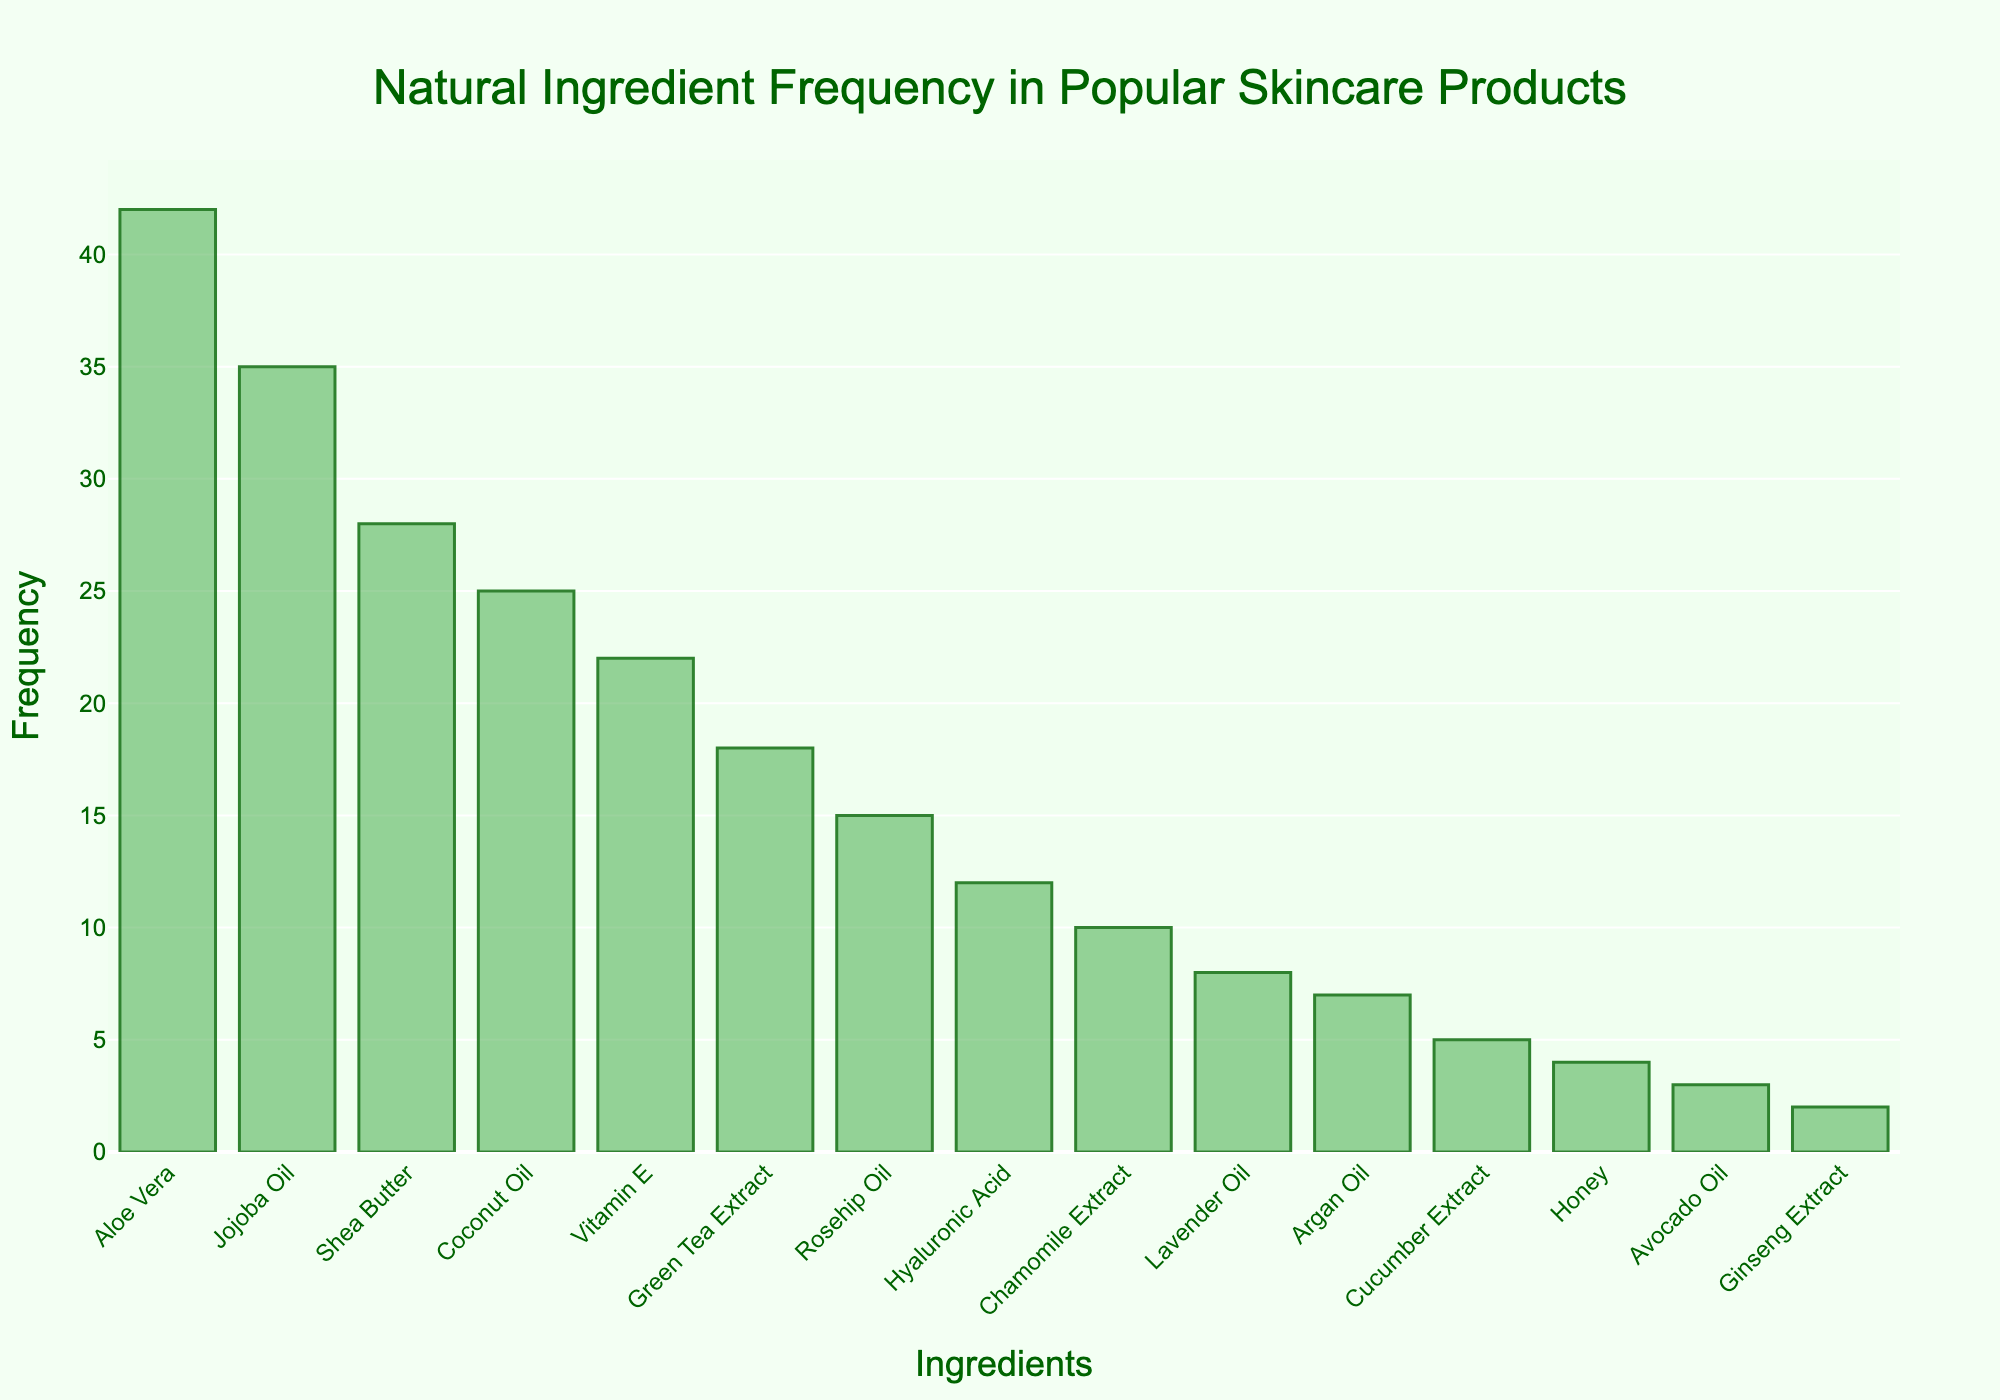What's the title of the histogram? The title is the text at the top of the plot. It gives an overview of what the histogram represents.
Answer: Natural Ingredient Frequency in Popular Skincare Products How many ingredients are plotted in the histogram? Count the number of bars in the figure, each representing a different ingredient.
Answer: 15 Which ingredient has the highest frequency? Identify the tallest bar in the histogram, as its height corresponds to the highest frequency.
Answer: Aloe Vera How many more times is Aloe Vera used compared to Green Tea Extract? Find the frequency of Aloe Vera and Green Tea Extract, then subtract the frequency of Green Tea Extract from Aloe Vera.
Answer: 24 What is the combined frequency of Jojoba Oil, Shea Butter, and Vitamin E? Add the frequencies of Jojoba Oil, Shea Butter, and Vitamin E (35 + 28 + 22).
Answer: 85 Which ingredients have a frequency of 10 or lower? Identify the bars in the histogram that are at or below the height corresponding to a frequency of 10.
Answer: Chamomile Extract, Lavender Oil, Argan Oil, Cucumber Extract, Honey, Avocado Oil, Ginseng Extract By how much does the frequency of Coconut Oil exceed that of Lavender Oil? Subtract the frequency of Lavender Oil from the frequency of Coconut Oil (25 - 8).
Answer: 17 Which ingredient appears exactly 12 times in the products? Look for the bar that reaches up to the frequency of 12 on the y-axis.
Answer: Hyaluronic Acid What is the average frequency of the top five ingredients in the histogram? Add the frequencies of the top five ingredients (42 + 35 + 28 + 25 + 22) and divide by 5.
Answer: 30.4 What percentage of the total frequency does Aloe Vera represent? Calculate the total frequency by adding the frequencies of all ingredients, then divide the frequency of Aloe Vera by this total and multiply by 100.
Answer: 18.3% 